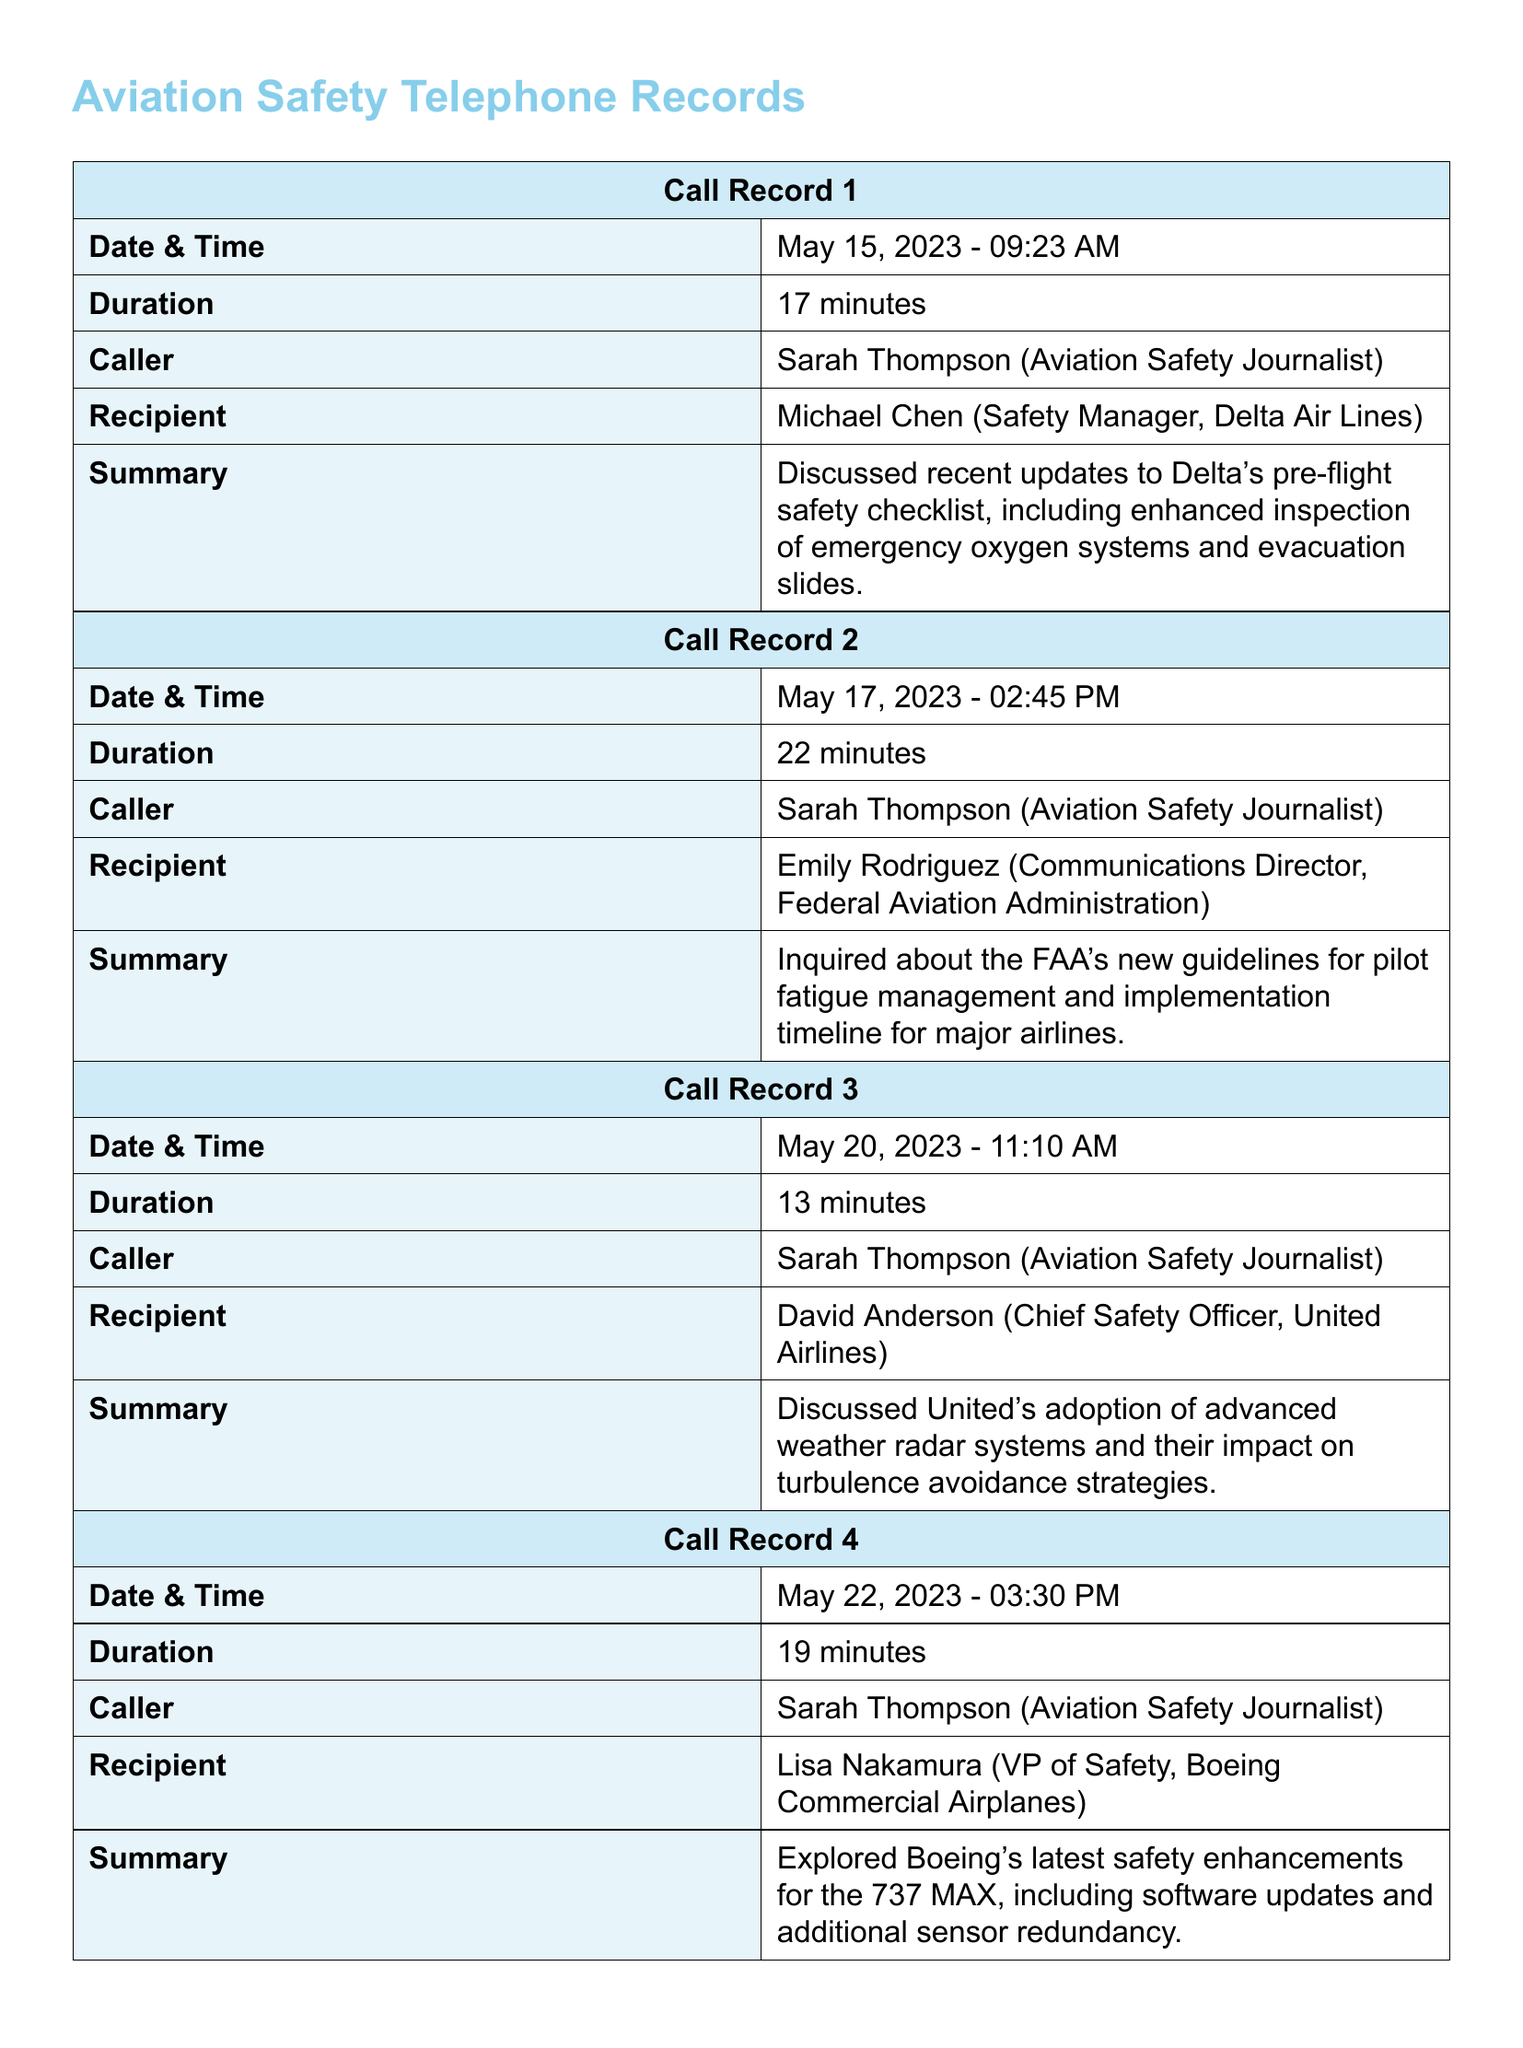What is the date of the first call? The date of the first call is mentioned in the records, which is May 15, 2023.
Answer: May 15, 2023 Who did Sarah Thompson speak with during the second call? The second call records show that Sarah Thompson spoke with Emily Rodriguez.
Answer: Emily Rodriguez What was discussed in the third call? The summary of the third call mentions the discussion of United's advanced weather radar systems and turbulence avoidance.
Answer: Advanced weather radar systems How long did the first call last? The duration of the first call is specified in the document as 17 minutes.
Answer: 17 minutes Which airline's safety enhancements were discussed in the fourth call? The fourth call specifically mentions that Boeing's safety enhancements were discussed.
Answer: Boeing What new guidelines were inquired about during the second call? The second call involved inquiries about the FAA's new guidelines for pilot fatigue management.
Answer: Pilot fatigue management Who is the recipient of the third call? The document indicates that the recipient of the third call is David Anderson.
Answer: David Anderson What time was the fourth call made? According to the records, the fourth call was made at 03:30 PM.
Answer: 03:30 PM How many minutes did the second call last? The duration of the second call is provided in the records as 22 minutes.
Answer: 22 minutes 